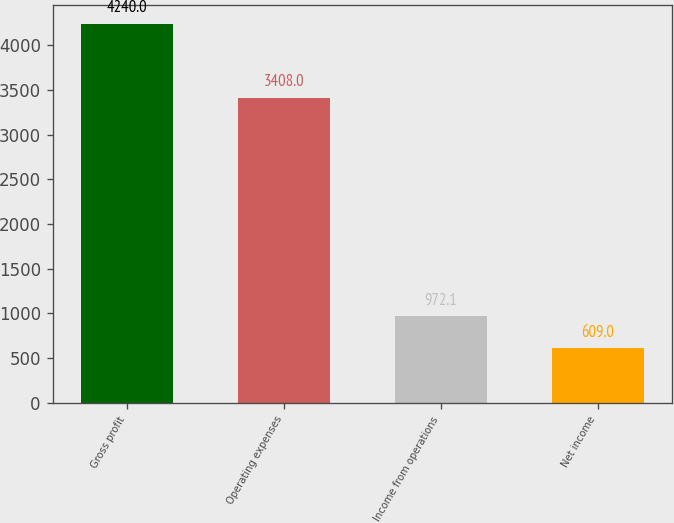Convert chart to OTSL. <chart><loc_0><loc_0><loc_500><loc_500><bar_chart><fcel>Gross profit<fcel>Operating expenses<fcel>Income from operations<fcel>Net income<nl><fcel>4240<fcel>3408<fcel>972.1<fcel>609<nl></chart> 